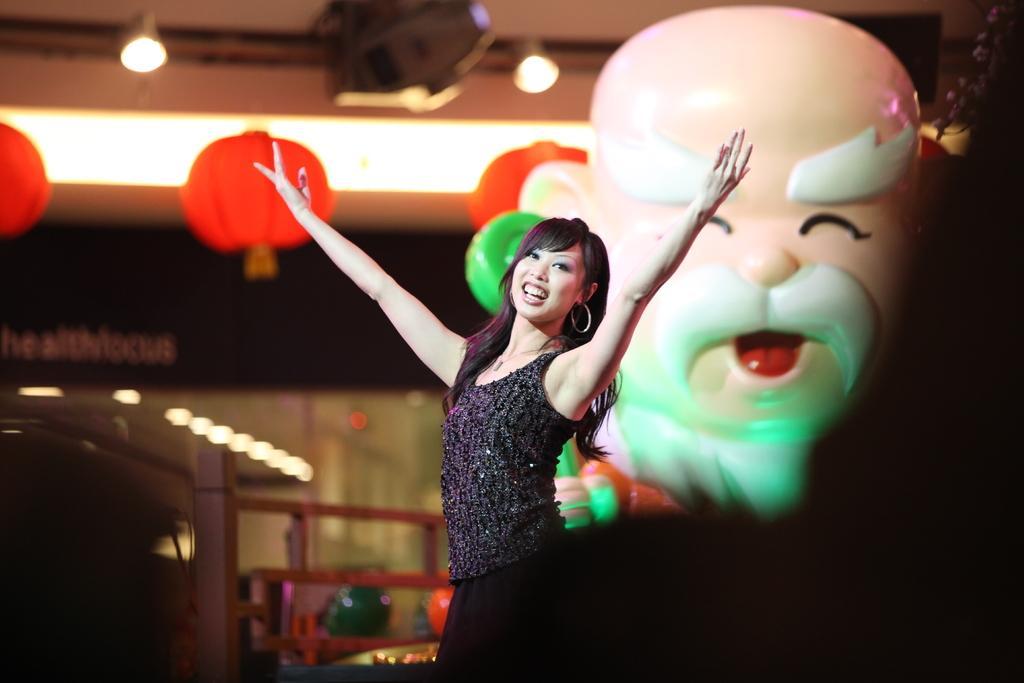Could you give a brief overview of what you see in this image? In this image there is a woman standing. Right side there is a statue of a person. Few lights are hanging from the roof. Left side there are lights attached to the wall. Bottom of the image there is a fence. 